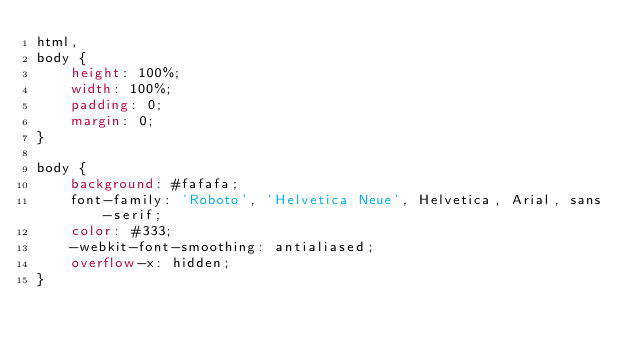Convert code to text. <code><loc_0><loc_0><loc_500><loc_500><_CSS_>html,
body {
    height: 100%;
    width: 100%;
    padding: 0;
    margin: 0;
}

body {
    background: #fafafa;
    font-family: 'Roboto', 'Helvetica Neue', Helvetica, Arial, sans-serif;
    color: #333;
    -webkit-font-smoothing: antialiased;
    overflow-x: hidden;
}

</code> 